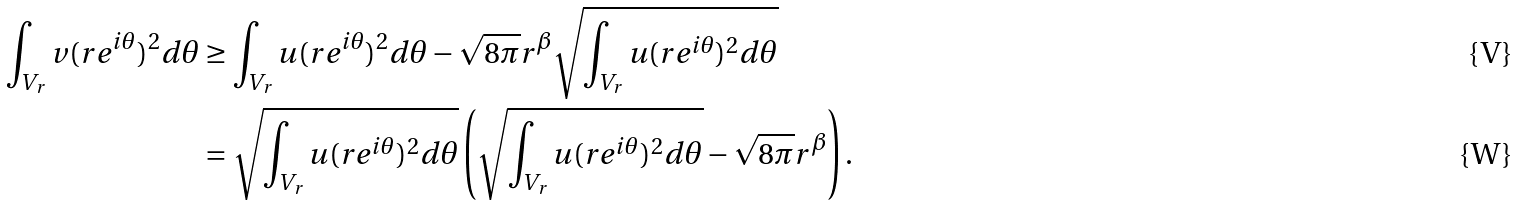<formula> <loc_0><loc_0><loc_500><loc_500>\int _ { V _ { r } } v ( r e ^ { i \theta } ) ^ { 2 } d \theta & \geq \int _ { V _ { r } } u ( r e ^ { i \theta } ) ^ { 2 } d \theta - \sqrt { 8 \pi } r ^ { \beta } \sqrt { \int _ { V _ { r } } u ( r e ^ { i \theta } ) ^ { 2 } d \theta } \\ & = \sqrt { \int _ { V _ { r } } u ( r e ^ { i \theta } ) ^ { 2 } d \theta } \left ( \sqrt { \int _ { V _ { r } } u ( r e ^ { i \theta } ) ^ { 2 } d \theta } - \sqrt { 8 \pi } r ^ { \beta } \right ) .</formula> 